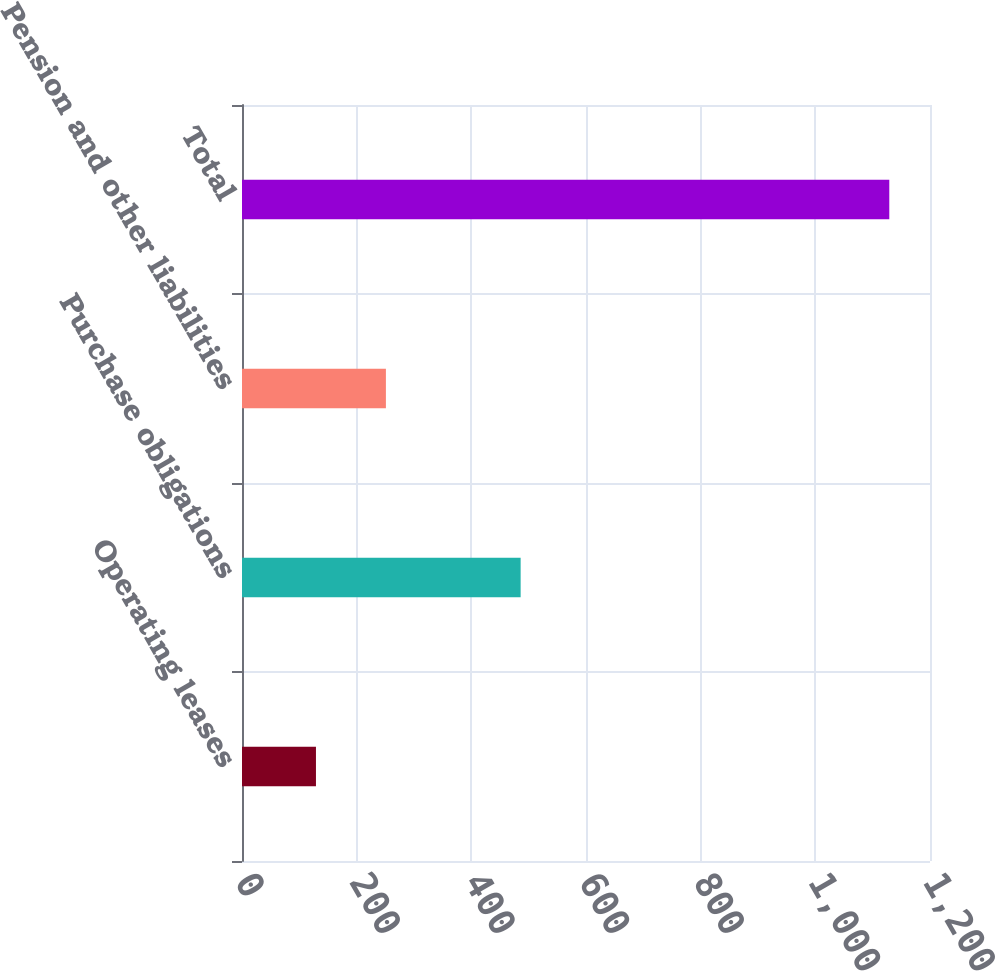<chart> <loc_0><loc_0><loc_500><loc_500><bar_chart><fcel>Operating leases<fcel>Purchase obligations<fcel>Pension and other liabilities<fcel>Total<nl><fcel>129<fcel>486<fcel>251<fcel>1129<nl></chart> 